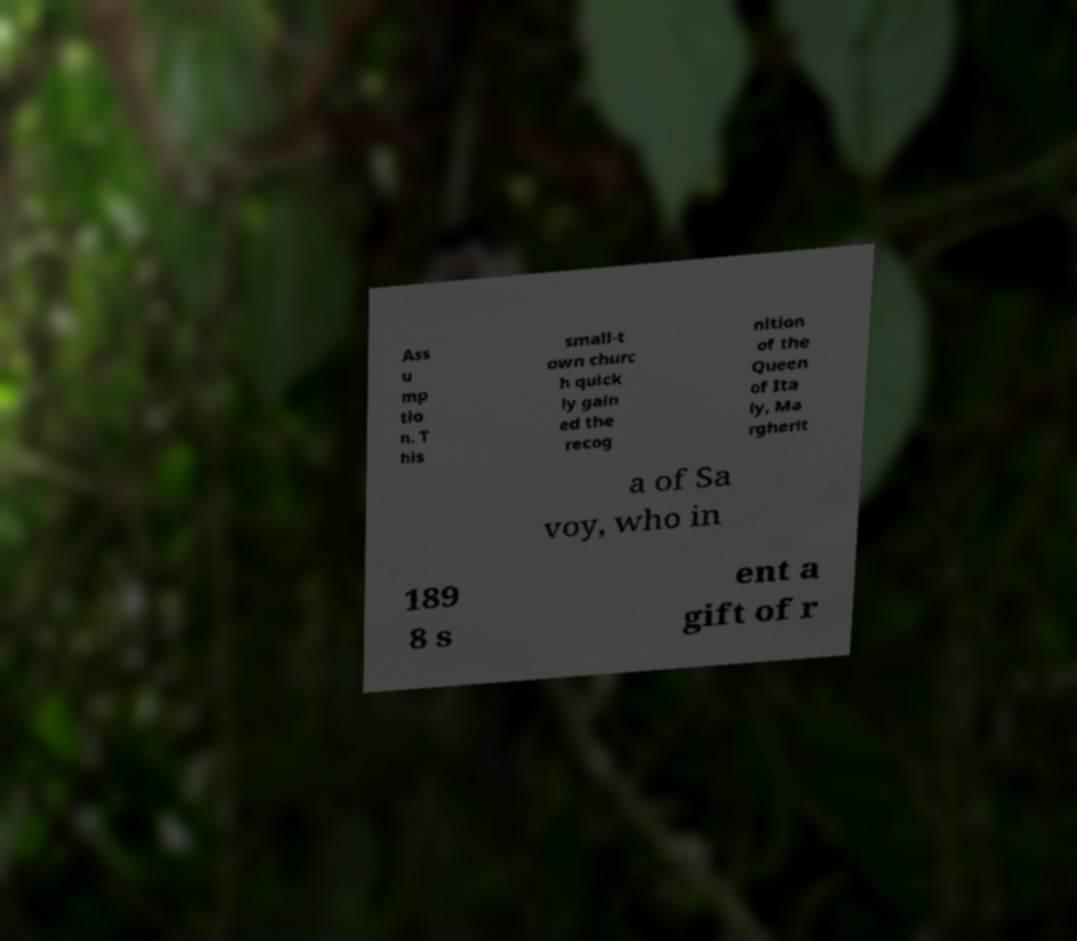For documentation purposes, I need the text within this image transcribed. Could you provide that? Ass u mp tio n. T his small-t own churc h quick ly gain ed the recog nition of the Queen of Ita ly, Ma rgherit a of Sa voy, who in 189 8 s ent a gift of r 